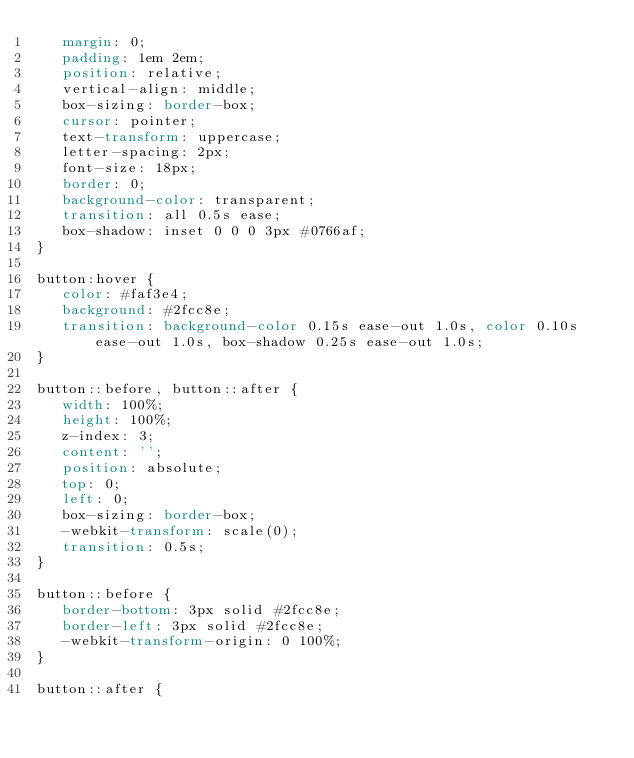Convert code to text. <code><loc_0><loc_0><loc_500><loc_500><_CSS_> 	 margin: 0;
 	 padding: 1em 2em;
 	 position: relative;
 	 vertical-align: middle;
 	 box-sizing: border-box;
 	 cursor: pointer;
 	 text-transform: uppercase;
 	 letter-spacing: 2px;
 	 font-size: 18px;
 	 border: 0;
 	 background-color: transparent;
 	 transition: all 0.5s ease;
 	 box-shadow: inset 0 0 0 3px #0766af;
}

button:hover {
	 color: #faf3e4;
	 background: #2fcc8e;
	 transition: background-color 0.15s ease-out 1.0s, color 0.10s ease-out 1.0s, box-shadow 0.25s ease-out 1.0s;
}

button::before, button::after {
	 width: 100%;
	 height: 100%;
	 z-index: 3;
	 content: '';
	 position: absolute;
	 top: 0;
	 left: 0;
	 box-sizing: border-box;
	 -webkit-transform: scale(0);
	 transition: 0.5s;
}

button::before {
	 border-bottom: 3px solid #2fcc8e;
	 border-left: 3px solid #2fcc8e;
	 -webkit-transform-origin: 0 100%;
}

button::after {</code> 